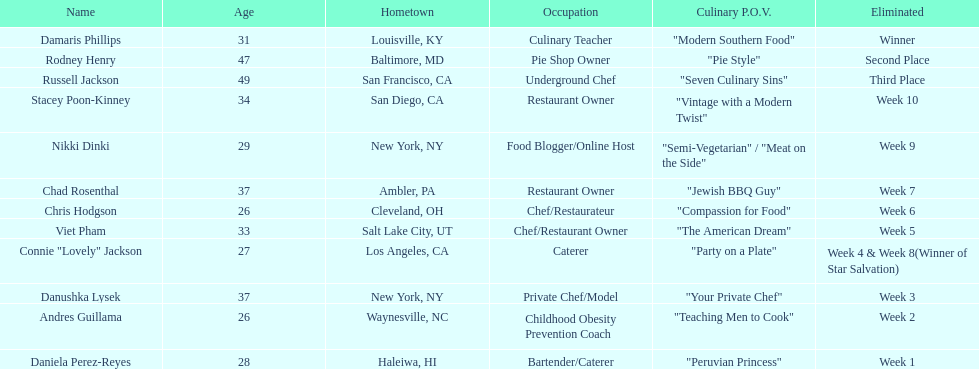Who among the competitors stayed in for just two weeks? Andres Guillama. 